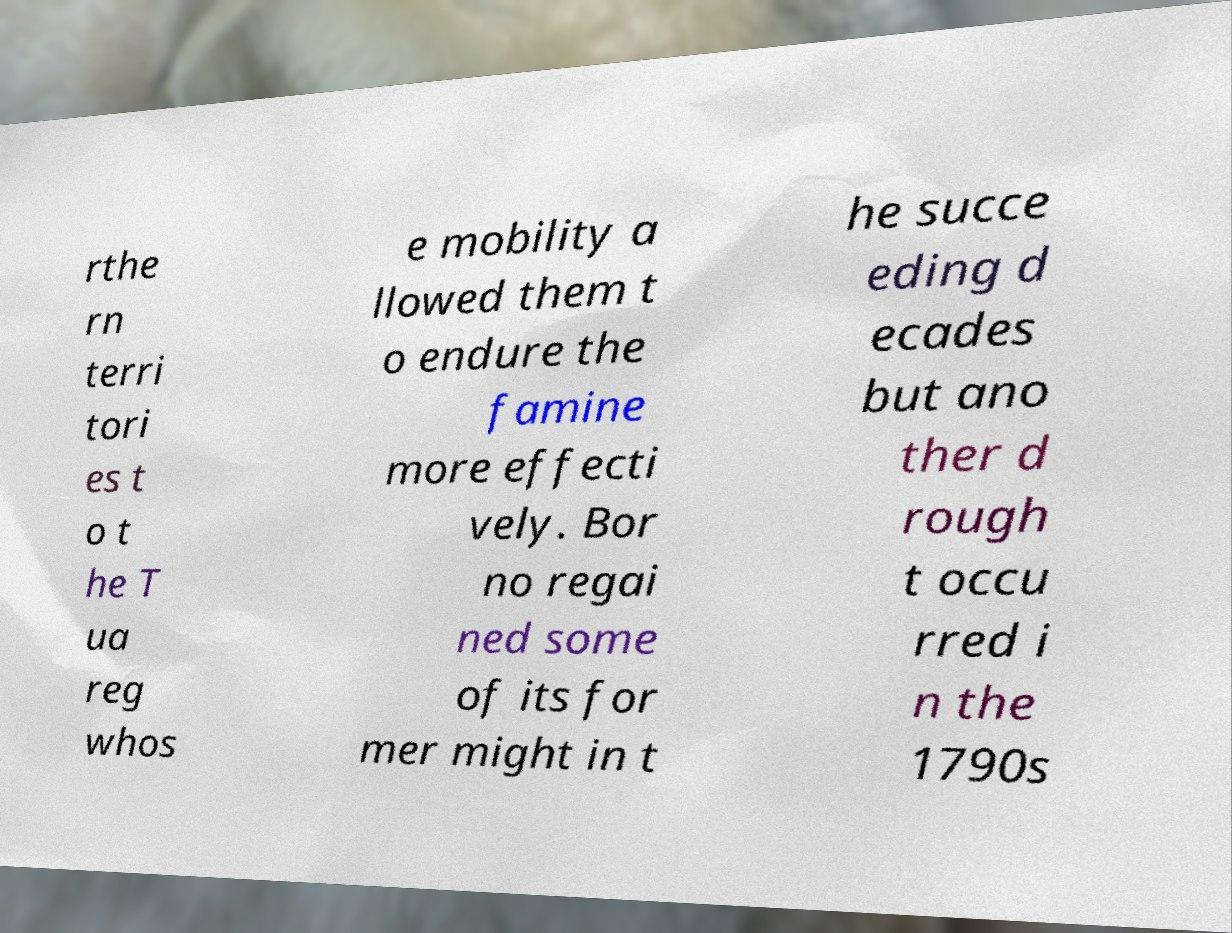I need the written content from this picture converted into text. Can you do that? rthe rn terri tori es t o t he T ua reg whos e mobility a llowed them t o endure the famine more effecti vely. Bor no regai ned some of its for mer might in t he succe eding d ecades but ano ther d rough t occu rred i n the 1790s 